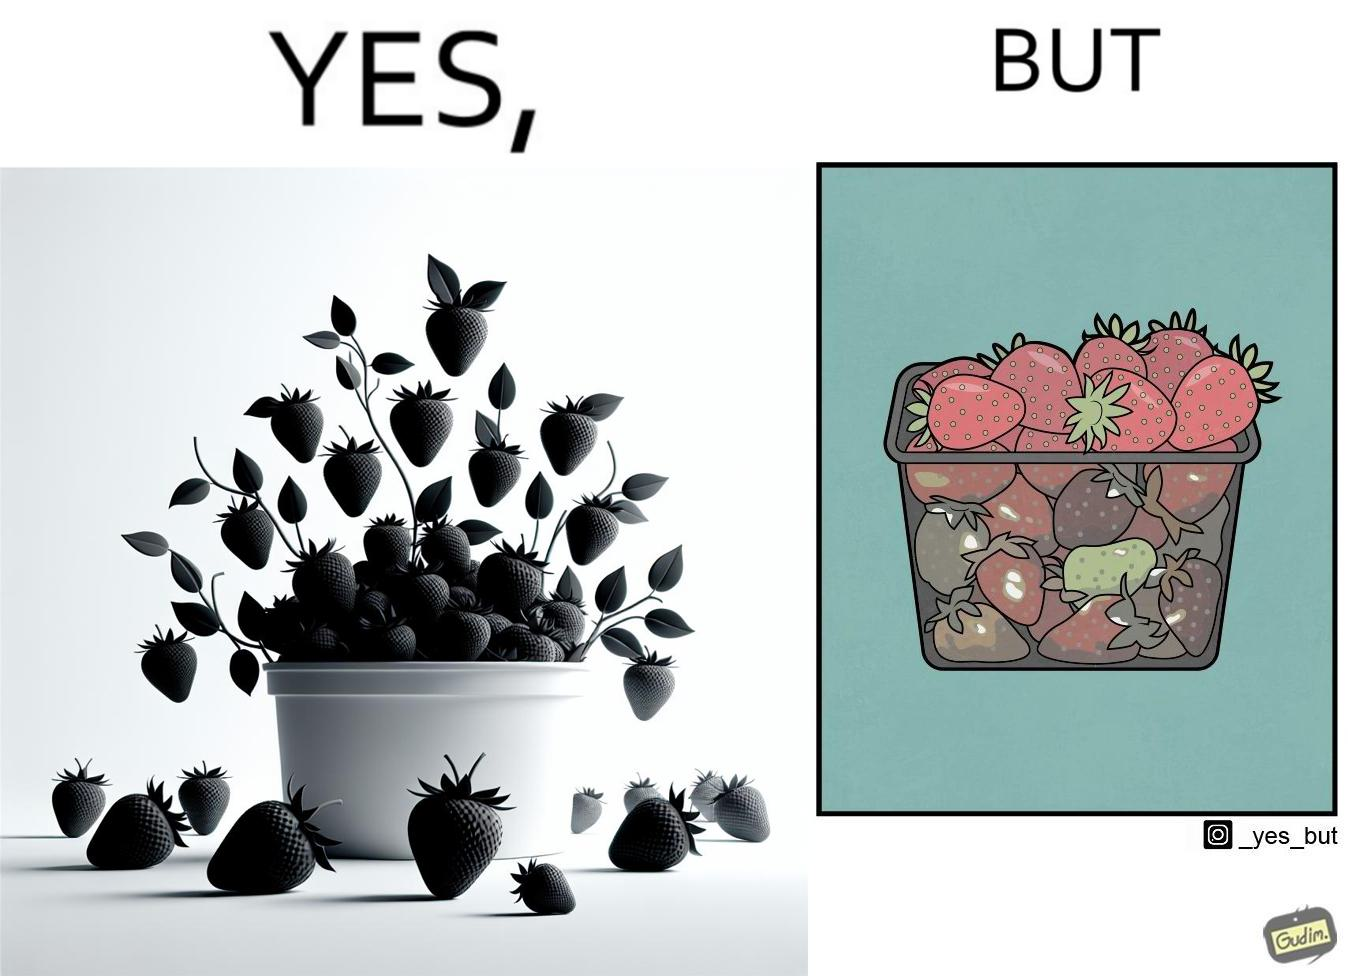Describe the satirical element in this image. the image is funny, as the strawberries in a container generally bought in retail appear fresh from the top, but the ones below them (which are generally not visible directly while buying the container of strawberries) are low quality/spoilt, revealing the tactics that retail uses to pass on low-quality products to innocent consumers. 